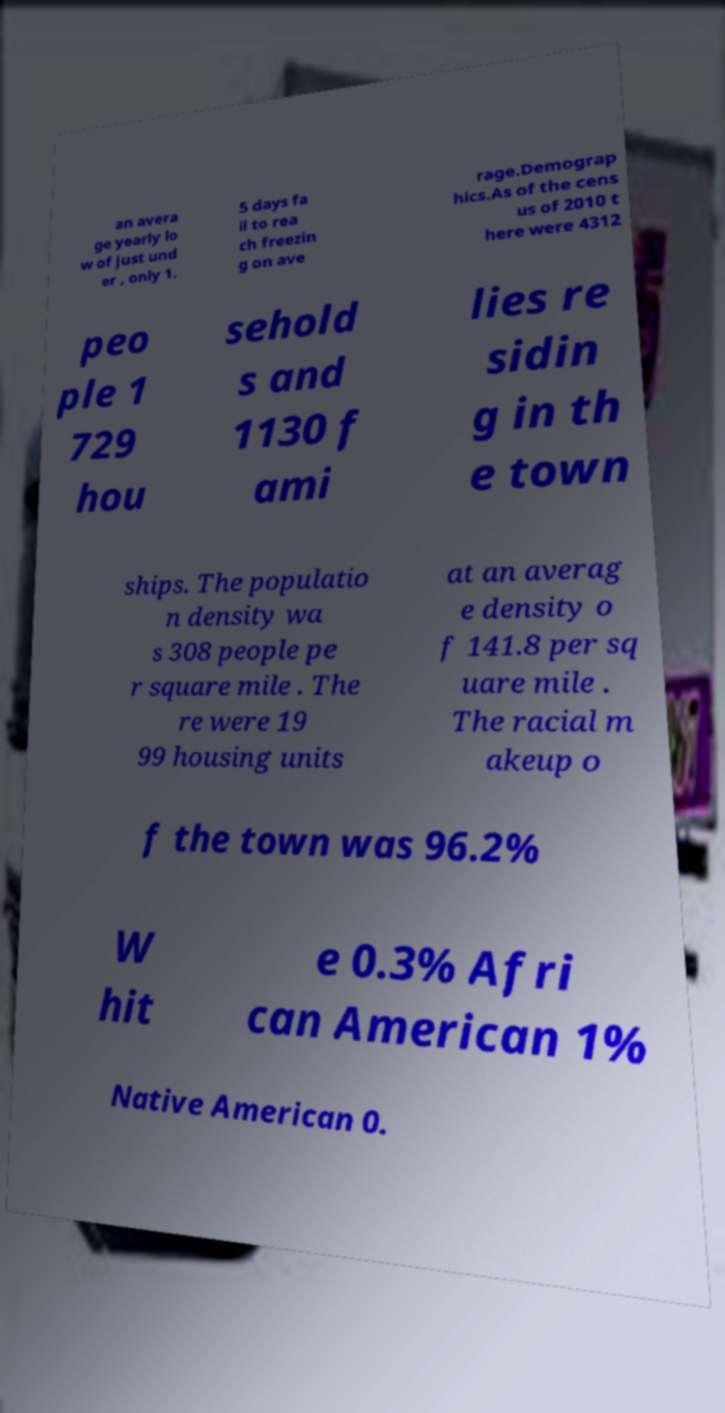For documentation purposes, I need the text within this image transcribed. Could you provide that? an avera ge yearly lo w of just und er , only 1. 5 days fa il to rea ch freezin g on ave rage.Demograp hics.As of the cens us of 2010 t here were 4312 peo ple 1 729 hou sehold s and 1130 f ami lies re sidin g in th e town ships. The populatio n density wa s 308 people pe r square mile . The re were 19 99 housing units at an averag e density o f 141.8 per sq uare mile . The racial m akeup o f the town was 96.2% W hit e 0.3% Afri can American 1% Native American 0. 